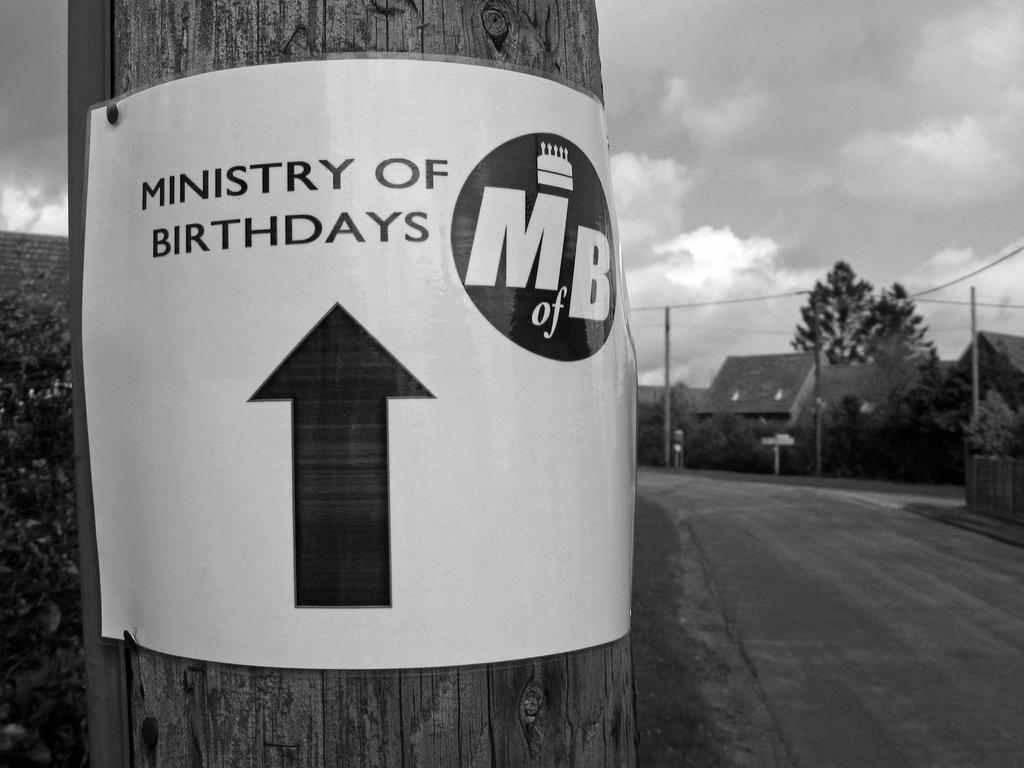<image>
Give a short and clear explanation of the subsequent image. a sign that has the ministry of birthdays on it 